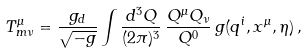<formula> <loc_0><loc_0><loc_500><loc_500>T ^ { \mu } _ { m \nu } = \frac { g _ { d } } { \sqrt { - g } } \int \frac { d ^ { 3 } Q } { ( 2 \pi ) ^ { 3 } } \, \frac { Q ^ { \mu } Q _ { \nu } } { Q ^ { 0 } } \, g ( q ^ { i } , x ^ { \mu } , \eta ) \, ,</formula> 